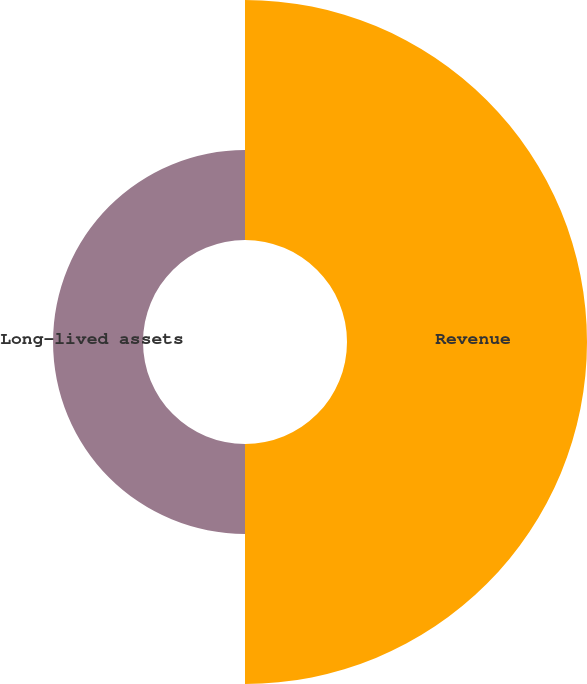Convert chart. <chart><loc_0><loc_0><loc_500><loc_500><pie_chart><fcel>Revenue<fcel>Long-lived assets<nl><fcel>72.74%<fcel>27.26%<nl></chart> 